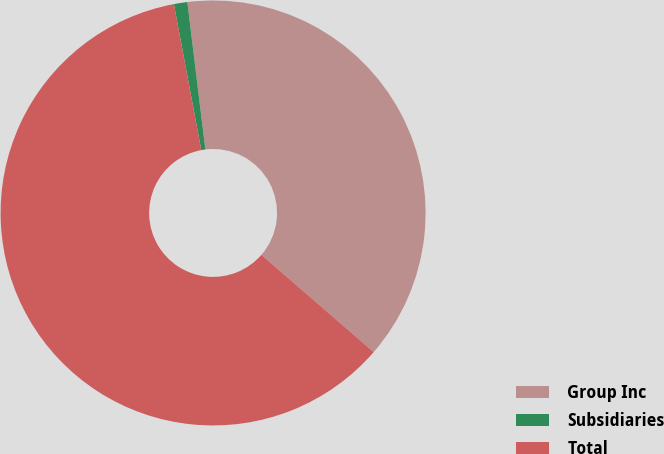Convert chart. <chart><loc_0><loc_0><loc_500><loc_500><pie_chart><fcel>Group Inc<fcel>Subsidiaries<fcel>Total<nl><fcel>38.3%<fcel>1.02%<fcel>60.69%<nl></chart> 